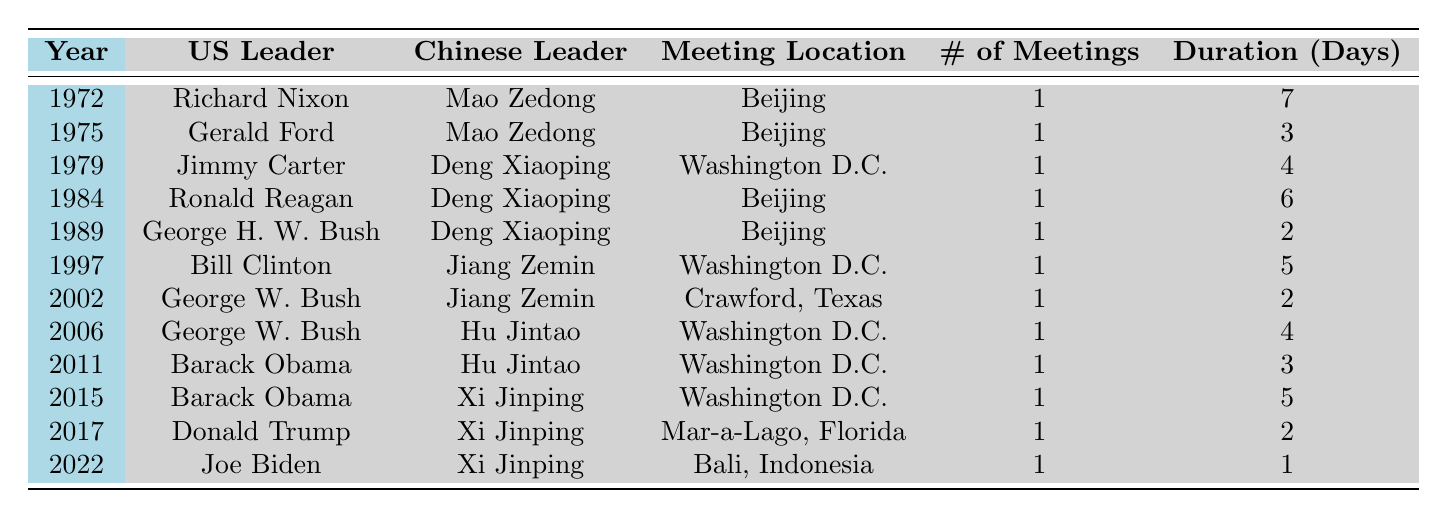What year did the first meeting between US and Chinese leaders occur? The first meeting occurred in 1972, as indicated in the table. The entry shows Richard Nixon as the US leader and Mao Zedong as the Chinese leader.
Answer: 1972 How many times did US leaders meet with Chinese leaders in the 1980s? The table lists meetings from the 1980s: 1984 (Reagan) and 1989 (Bush), making a total of 2 meetings in that decade.
Answer: 2 Which Chinese leader had the most meetings with US leaders based on the table? The table shows that Deng Xiaoping met with US leaders three times (1979, 1984, 1989), more than any other Chinese leader.
Answer: Deng Xiaoping What was the duration of the meeting between Barack Obama and Xi Jinping in 2015? According to the table, the meeting between Barack Obama and Xi Jinping in 2015 lasted for 5 days.
Answer: 5 Is it true that Joe Biden's meeting with Xi Jinping in 2022 was the shortest in duration? Yes, the table shows that the meeting in 2022 lasted only 1 day, making it the shortest compared to other meetings listed in the table.
Answer: Yes What was the average duration of meetings between US and Chinese leaders from 1972 to 2022? First, we sum the durations: 7 + 3 + 4 + 6 + 2 + 5 + 2 + 4 + 3 + 5 + 2 + 1 = 44 days. Then, since there are 12 meetings, we divide by 12 to obtain the average: 44/12 ≈ 3.67 days.
Answer: Approximately 3.67 days How many meetings occurred in Washington D.C. from the table? The table shows three meetings in Washington D.C. in 1979 (Carter), 1997 (Clinton), 2006 (Bush), and 2011 (Obama), totaling 4 meetings in that location.
Answer: 4 Which US leader met with the most different Chinese leaders, according to the table? Barack Obama met with two different Chinese leaders: Hu Jintao (2011) and Xi Jinping (2015). Other US leaders met with fewer unique leaders than this.
Answer: Barack Obama Was there any meeting between US and Chinese leaders in the year 2020? The table does not have any entry for the year 2020, indicating that there were no recorded meetings that year.
Answer: No Which meeting had the longest duration, and how long was it? The meeting in 1972 between Richard Nixon and Mao Zedong lasted for 7 days, which is the longest duration listed in the table.
Answer: 7 days How many years went by without any meetings from 1972 to 2022? The meetings occurred in the years specified without any breaks listed. There are no gaps going beyond 4 years between meetings according to the records, leading to just 2 periods without meetings (1980-1983 and 1997-2001).
Answer: 2 periods 